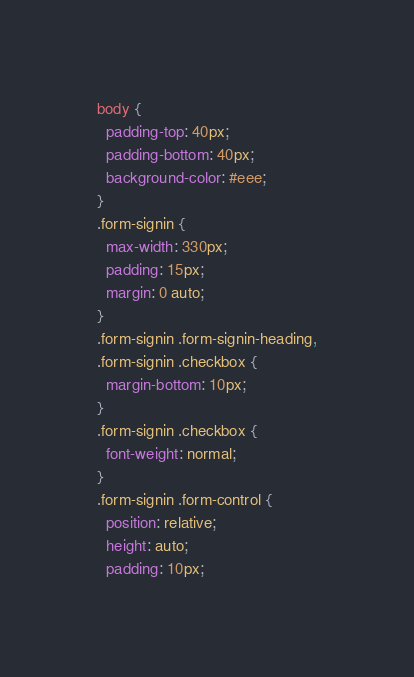Convert code to text. <code><loc_0><loc_0><loc_500><loc_500><_CSS_>body {
  padding-top: 40px;
  padding-bottom: 40px;
  background-color: #eee;
}
.form-signin {
  max-width: 330px;
  padding: 15px;
  margin: 0 auto;
}
.form-signin .form-signin-heading,
.form-signin .checkbox {
  margin-bottom: 10px;
}
.form-signin .checkbox {
  font-weight: normal;
}
.form-signin .form-control {
  position: relative;
  height: auto;
  padding: 10px;</code> 